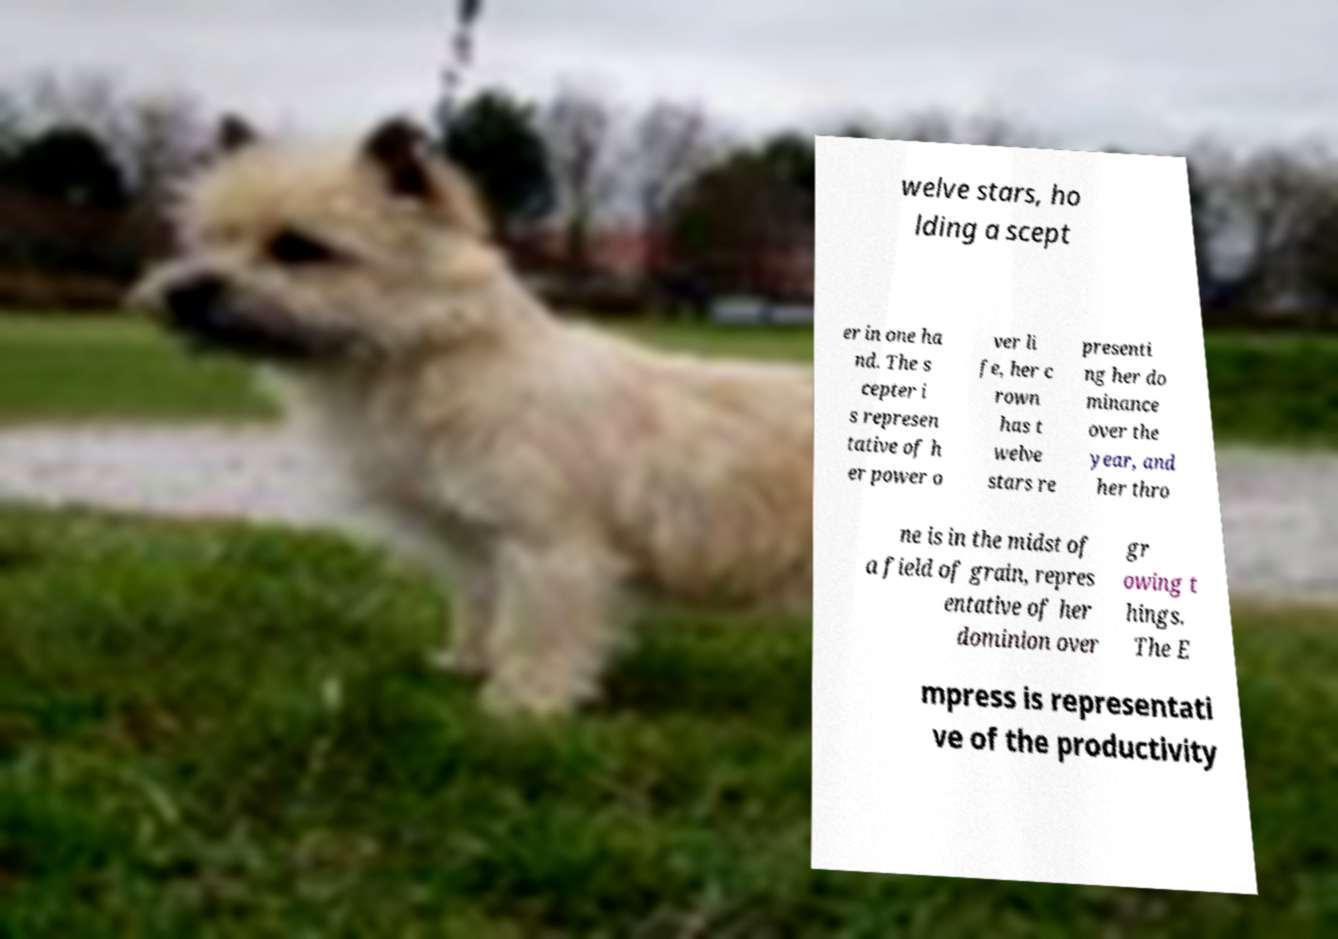Could you assist in decoding the text presented in this image and type it out clearly? welve stars, ho lding a scept er in one ha nd. The s cepter i s represen tative of h er power o ver li fe, her c rown has t welve stars re presenti ng her do minance over the year, and her thro ne is in the midst of a field of grain, repres entative of her dominion over gr owing t hings. The E mpress is representati ve of the productivity 